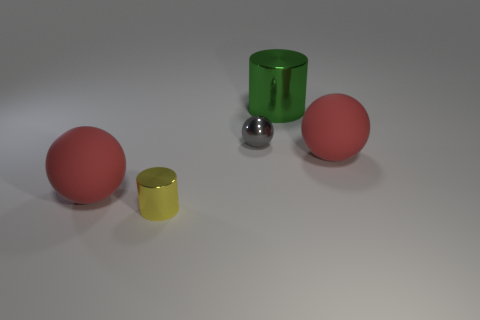Are there any other things that have the same material as the tiny yellow cylinder?
Your response must be concise. Yes. There is another thing that is the same size as the yellow thing; what color is it?
Give a very brief answer. Gray. Are there any metallic cylinders of the same color as the small sphere?
Provide a short and direct response. No. The gray thing that is made of the same material as the yellow object is what size?
Your answer should be very brief. Small. How many other objects are there of the same size as the green object?
Make the answer very short. 2. What material is the small object on the right side of the yellow metal cylinder?
Keep it short and to the point. Metal. What is the shape of the big thing in front of the red object that is right of the small metal cylinder that is on the left side of the big green thing?
Keep it short and to the point. Sphere. Is the size of the green cylinder the same as the gray thing?
Your answer should be very brief. No. How many things are purple things or large spheres that are to the right of the small yellow thing?
Your answer should be compact. 1. How many objects are large matte balls that are on the left side of the small cylinder or small yellow shiny objects that are on the left side of the gray ball?
Give a very brief answer. 2. 